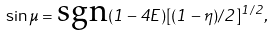<formula> <loc_0><loc_0><loc_500><loc_500>\ \sin \mu = \text {sgn} ( 1 - 4 E ) [ ( 1 - \eta ) / 2 ] ^ { 1 / 2 } , \quad</formula> 